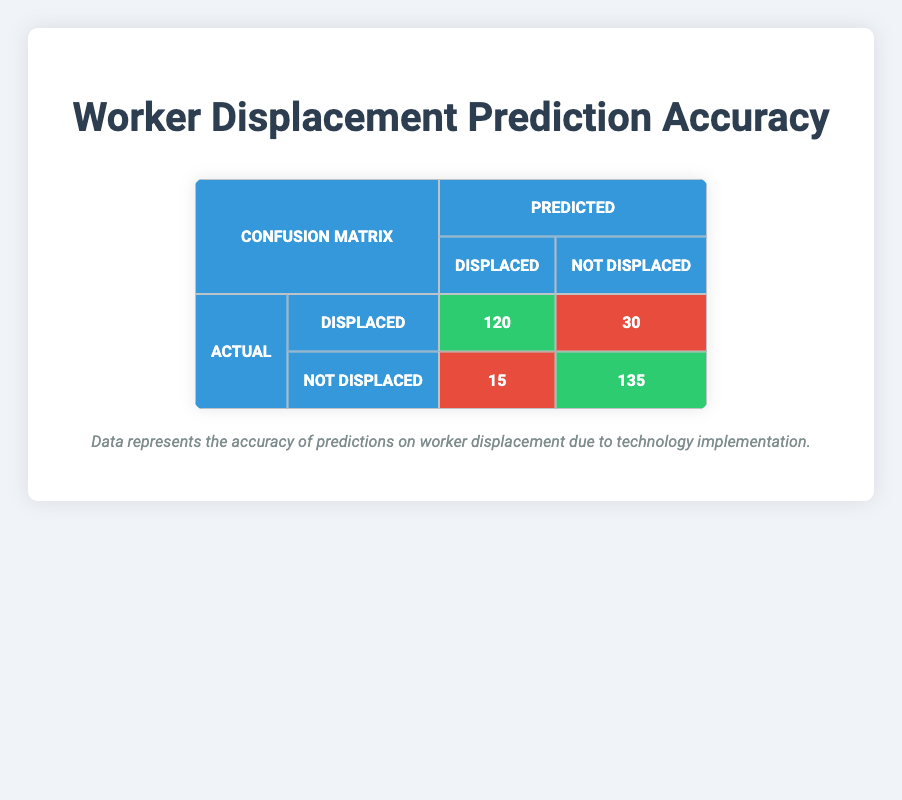What is the value for true positives in the confusion matrix? The true positives are identified by the intersection of the actual displaced and the predicted displaced category. According to the table, the value for true positives is 120.
Answer: 120 How many workers were correctly predicted as not displaced? The correct predictions for not displaced workers are indicated by the true negatives, which are found in the actual not displaced and predicted not displaced category. The value for true negatives is 135.
Answer: 135 What is the total number of workers predicted as displaced? To find the total number of workers predicted as displaced, we sum the true positives (120) and false positives (15). Therefore, the total is 120 + 15 = 135.
Answer: 135 What is the false negative rate? The false negative rate is calculated by taking the number of false negatives (30) and dividing it by the total actual positives (true positives + false negatives = 120 + 30 = 150). Thus, the false negative rate is 30/150, which simplifies to 0.2 or 20%.
Answer: 20% Is the number of false positives greater than the number of true positives? The number of false positives is 15, and the number of true positives is 120. Since 15 is not greater than 120, the statement is false.
Answer: No What is the accuracy of the model? The accuracy is calculated as the sum of true positives and true negatives divided by the total number of observations. Thus, the accuracy is (120 + 135) / (120 + 30 + 15 + 135) = 255 / 300 = 0.85 or 85%.
Answer: 85% How many workers were incorrectly predicted as not displaced? To find the number of workers incorrectly predicted as not displaced, we refer to the false negatives, which is the count of actual displaced workers predicted as not displaced. The value for false negatives is 30.
Answer: 30 What is the total number of workers considered in the predictions? The total number of workers is the sum of all four categories: true positives (120), false negatives (30), false positives (15), and true negatives (135). Adding these together gives us 120 + 30 + 15 + 135 = 300.
Answer: 300 What percentage of the actual displaced workers were predicted correctly? To find this percentage, divide the true positives (120) by the total actual displaced workers (true positives + false negatives = 120 + 30 = 150). The calculation is (120 / 150) * 100, which equals 80%.
Answer: 80% 